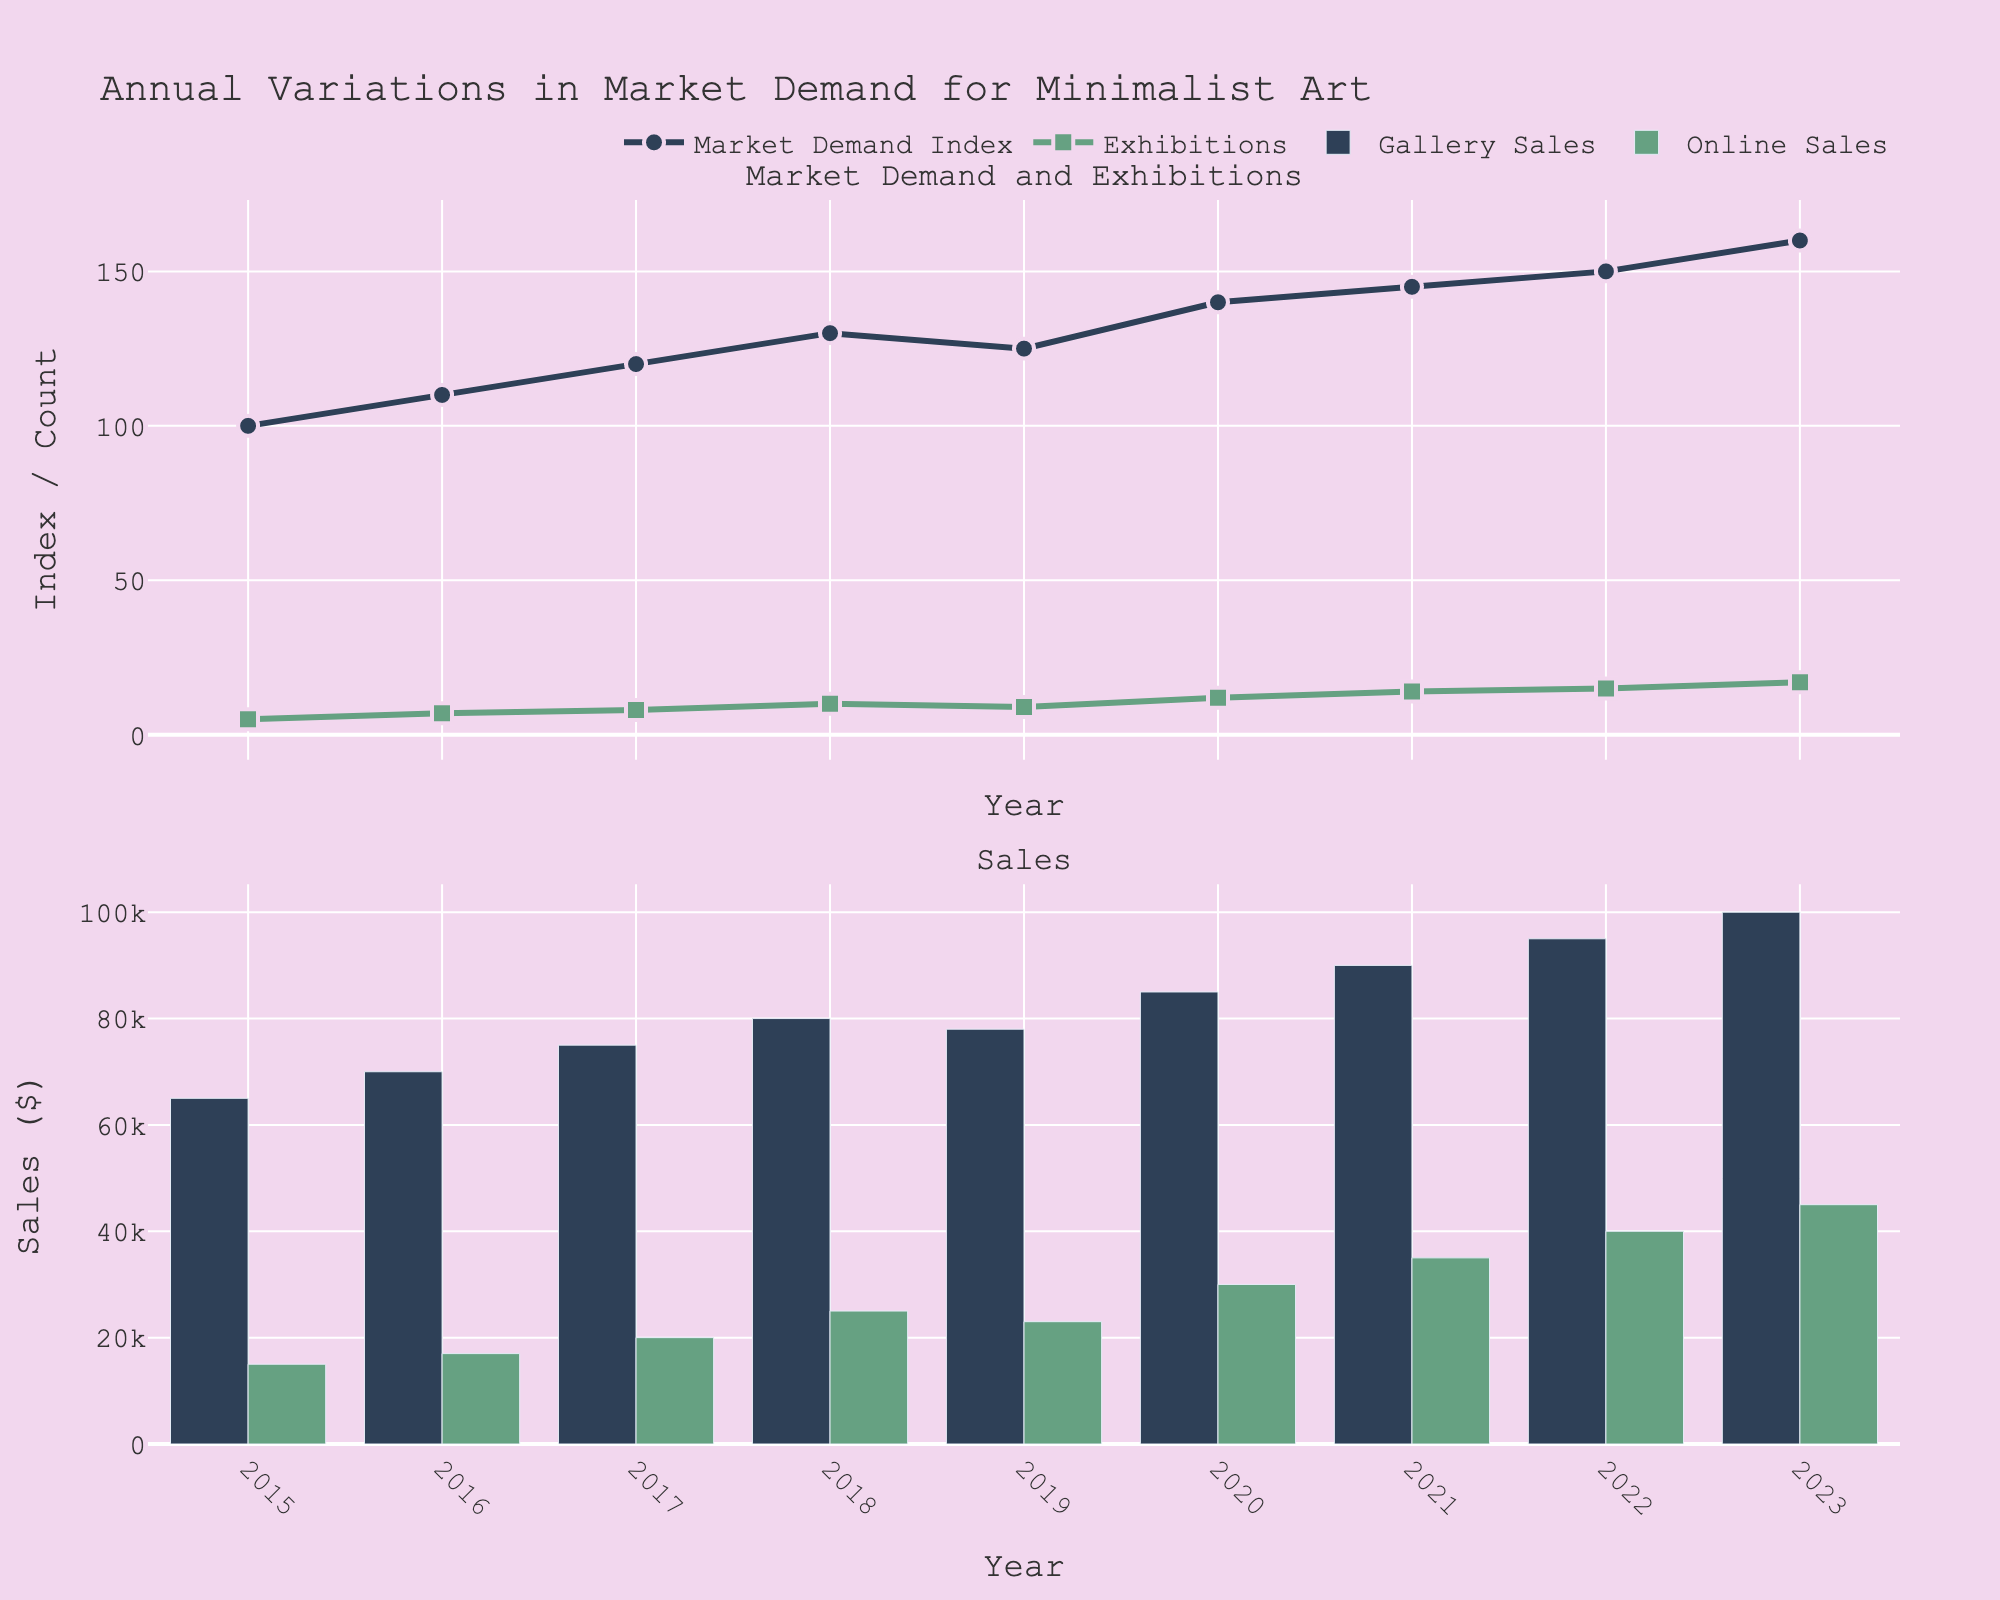What is the title of the figure? The title is located at the top of the figure and provides a brief overview of what the plot represents.
Answer: Annual Variations in Market Demand for Minimalist Art How many total exhibitions were held from 2015 to 2023? Count the number of exhibitions for each year and sum them up: 5+7+8+10+9+12+14+15+17.
Answer: 97 What is the trend in Market Demand Index over the years? Observe the plotted line for Market Demand Index from 2015 to 2023 and describe whether it is increasing, decreasing, or stable.
Answer: Increasing In which year did Online Sales first exceed $30,000? Look at the bar chart for Online Sales and identify the first year where the bar height exceeds the $30,000 mark.
Answer: 2020 How do Gallery Sales in 2023 compare to Gallery Sales in 2015? Compare the heights of the bars for Gallery Sales in the years 2015 and 2023.
Answer: Higher in 2023 Which year had the highest number of exhibitions? Check the plot for Exhibitions and identify the year with the highest value.
Answer: 2023 What is the difference in Market Demand Index between 2023 and 2019? Subtract the Market Demand Index of 2019 from that of 2023: 160 - 125.
Answer: 35 In which year was there a notable decrease in Market Demand Index? Identify the year where there is a visible drop in the Market Demand Index line plot.
Answer: 2019 Are Online Sales and Gallery Sales both increasing year over year? Observe the bar charts for Online Sales and Gallery Sales and describe their trends annually.
Answer: Yes Between 2015 and 2023, during which years did the Market Demand Index remain constant or decrease? Identify the periods where the Market Demand Index line is either flat or decreases, specifically noticing differences or lack of increase.
Answer: 2019 